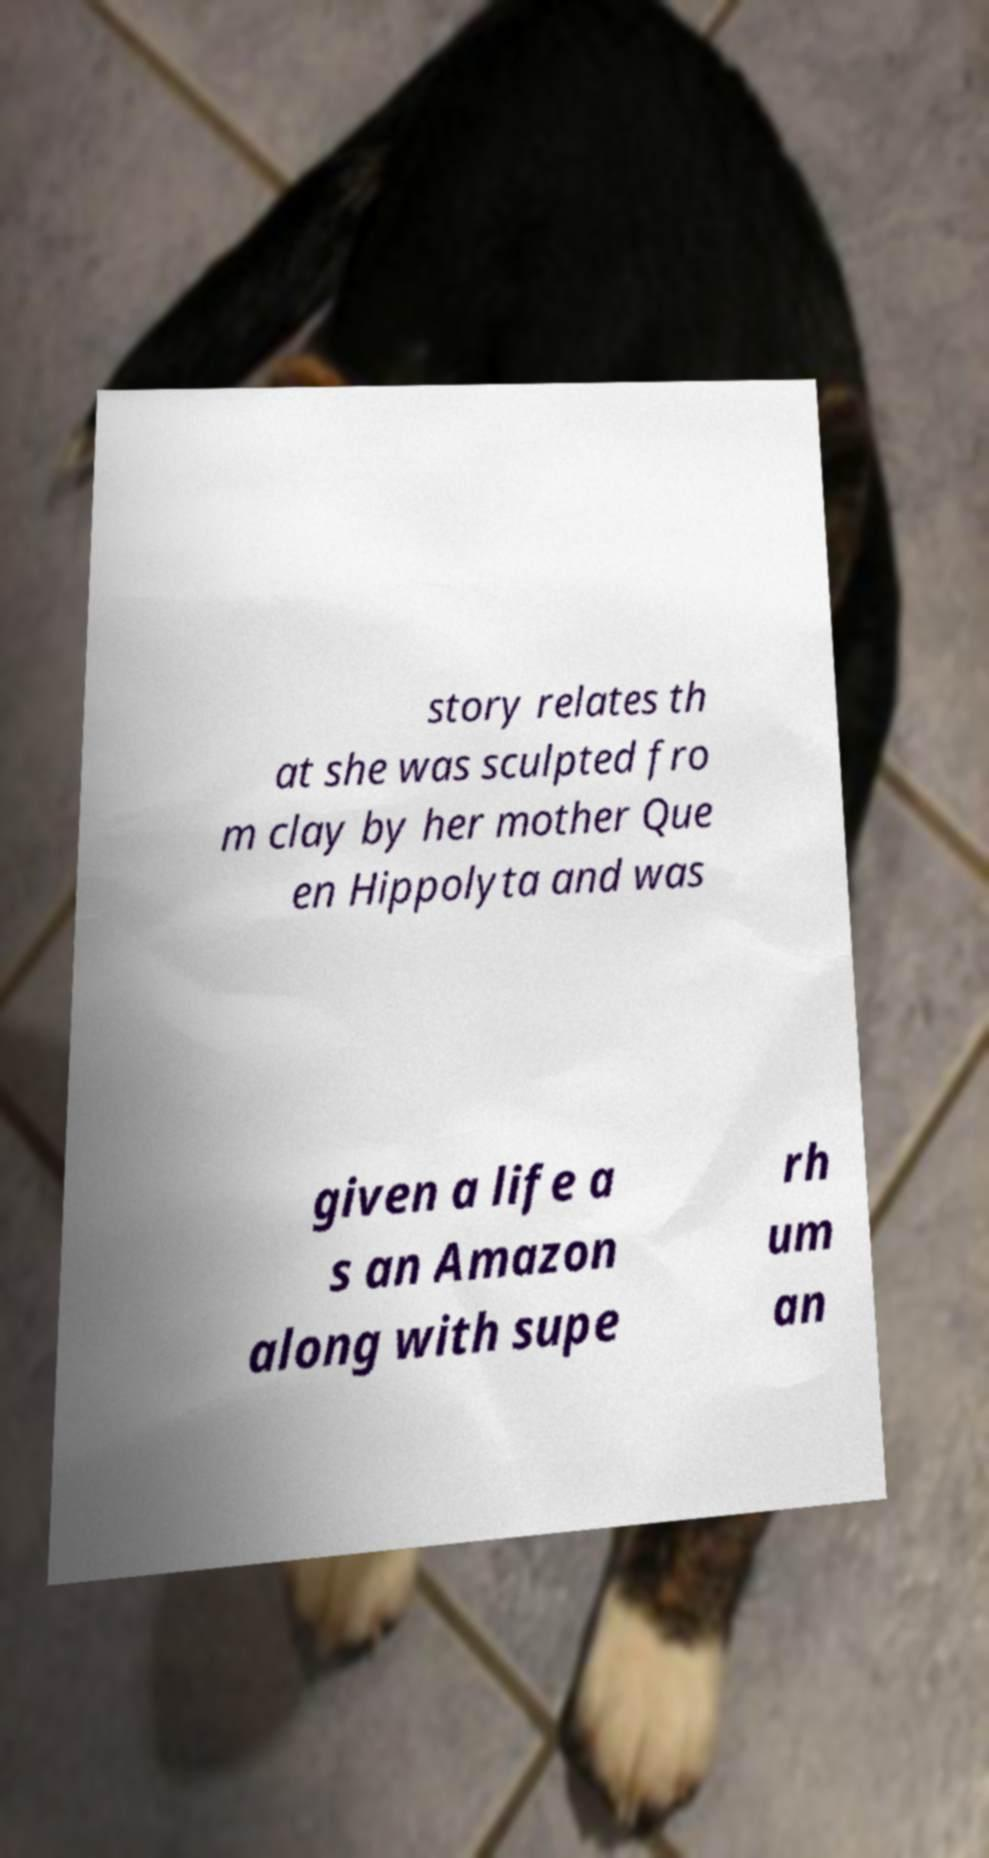For documentation purposes, I need the text within this image transcribed. Could you provide that? story relates th at she was sculpted fro m clay by her mother Que en Hippolyta and was given a life a s an Amazon along with supe rh um an 